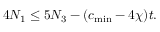Convert formula to latex. <formula><loc_0><loc_0><loc_500><loc_500>4 N _ { 1 } \leq 5 N _ { 3 } - ( c _ { \min } - 4 \chi ) t .</formula> 